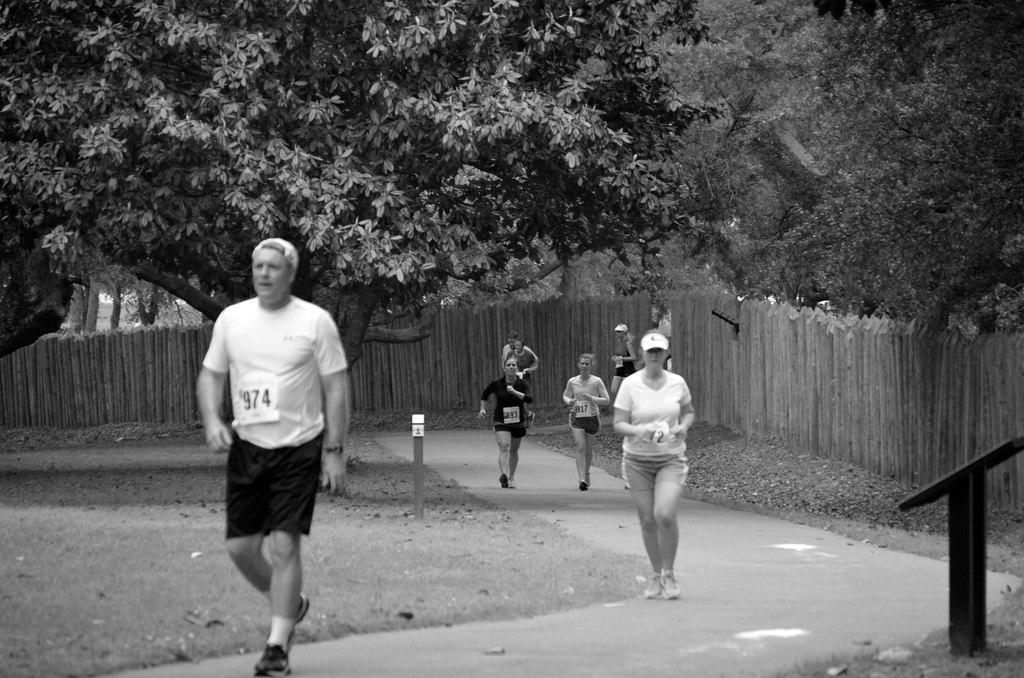How would you summarize this image in a sentence or two? In this image, we can see people jogging on the road. In the background, there are trees. 